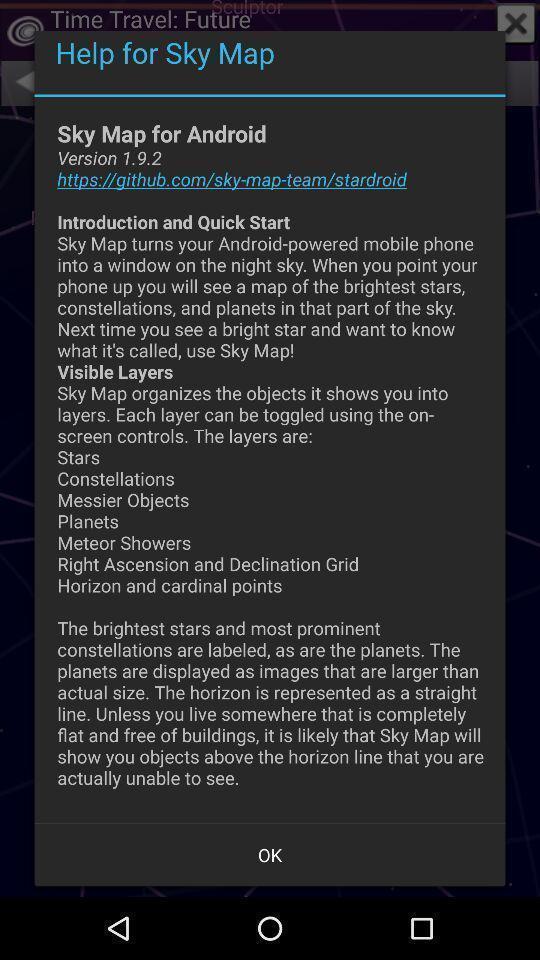Summarize the information in this screenshot. Popup showing the introduction and quick start. 